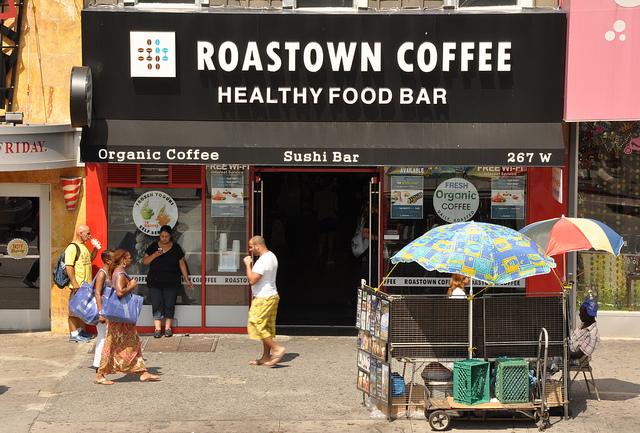What color is the umbrella?
Concise answer only. Blue. What drink do they feature?
Give a very brief answer. Coffee. What color is the womans umbrella?
Short answer required. Blue. Where is the word "FRIDAY" written?
Write a very short answer. To left. Was this photo taken in the US?
Quick response, please. Yes. How many people are seated in this picture?
Concise answer only. 1. What color is the woman's purse?
Give a very brief answer. Blue. Are there more men than women in this photo?
Give a very brief answer. No. 